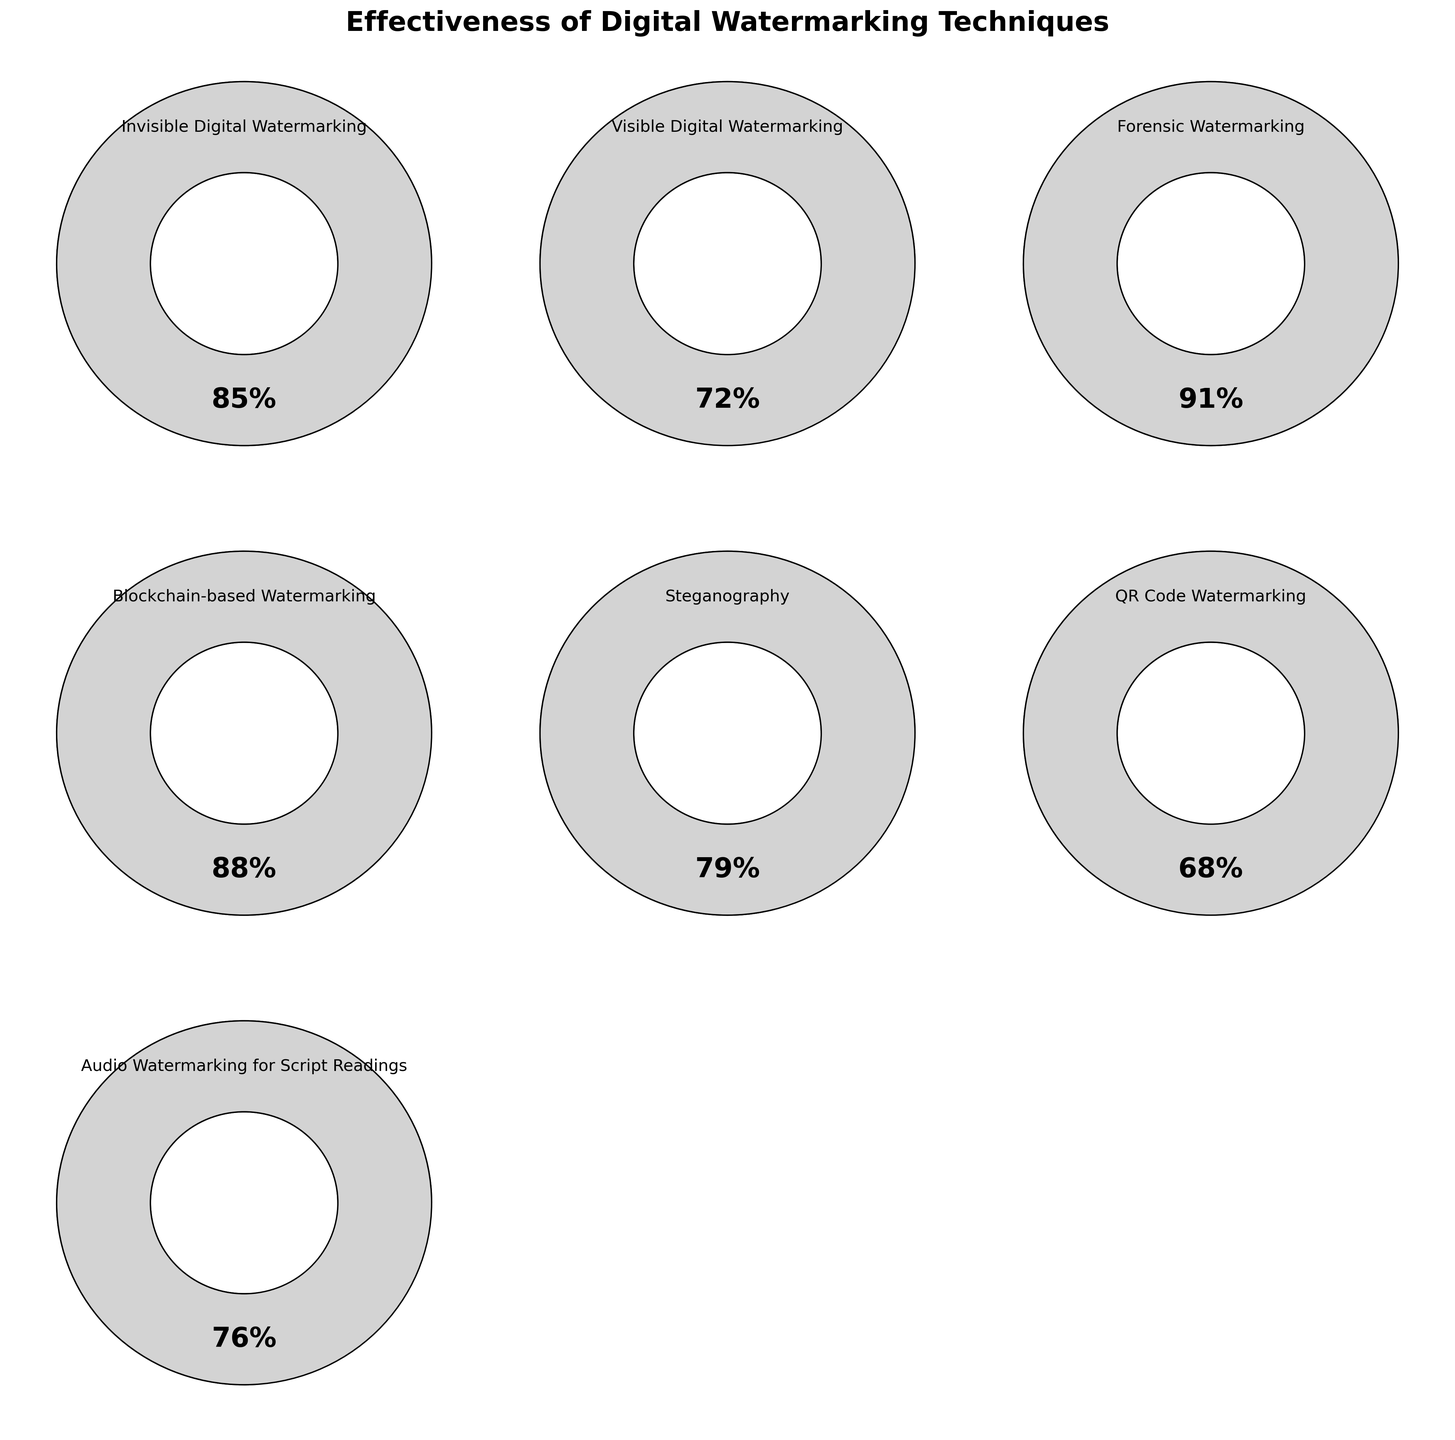Which digital watermarking technique has the highest effectiveness? By looking at the figure, see which gauge is closest to the 100% mark. The Forensic Watermarking technique is closest at 91% effectiveness.
Answer: Forensic Watermarking What is the effectiveness of Invisible Digital Watermarking? Locate the gauge corresponding to Invisible Digital Watermarking and read the effectiveness value displayed. It shows 85%.
Answer: 85% How many techniques have an effectiveness higher than 80%? Count the gauges whose values surpass the 80% mark. Invisible Digital Watermarking (85%), Forensic Watermarking (91%), and Blockchain-based Watermarking (88%) meet this criterion, so there are 3 techniques.
Answer: 3 Which technique is least effective according to the figure? Compare all the effectiveness values and identify the lowest. QR Code Watermarking, with an effectiveness of 68%, is the least effective.
Answer: QR Code Watermarking What is the combined effectiveness of Steganography and Audio Watermarking for Script Readings? Find the effectiveness values for Steganography (79%) and Audio Watermarking for Script Readings (76%), and add them together. The sum is 155%.
Answer: 155% What is the difference in effectiveness between the most effective and least effective techniques? Identify the effectiveness values of the most effective (Forensic Watermarking at 91%) and the least effective (QR Code Watermarking at 68%) techniques. Subtract the smallest value from the largest: 91% - 68% = 23%.
Answer: 23% Which techniques fall below the average effectiveness of the top three techniques? First, find the top three highest effectiveness values: Forensic Watermarking (91%), Blockchain-based Watermarking (88%), and Invisible Digital Watermarking (85%). Calculate the average: (91% + 88% + 85%) / 3 = 88%. Identify the techniques with values lower than 88%: Visible Digital Watermarking (72%), Steganography (79%), QR Code Watermarking (68%), and Audio Watermarking for Script Readings (76%).
Answer: Visible Digital Watermarking, Steganography, QR Code Watermarking, Audio Watermarking for Script Readings What percentage higher is Blockchain-based Watermarking's effectiveness compared to QR Code Watermarking? Identify the effectiveness values for Blockchain-based Watermarking (88%) and QR Code Watermarking (68%). Calculate the percentage increase: (88% - 68%) / 68% * 100 = 29.4%.
Answer: 29.4% What is the median effectiveness value among the techniques? List all effectiveness values in ascending order: 68%, 72%, 76%, 79%, 85%, 88%, 91%. The median is the middle value, which is 79%.
Answer: 79% 